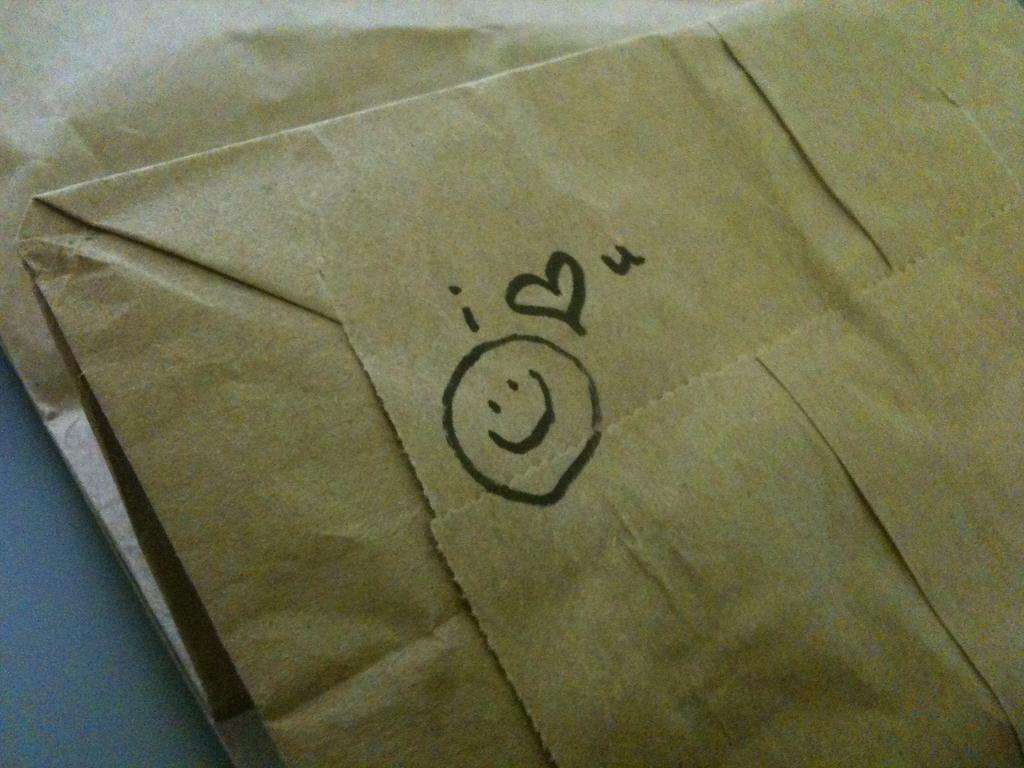<image>
Present a compact description of the photo's key features. A smiley face and a message saying I love you is on the  bottom of a paper bag. 